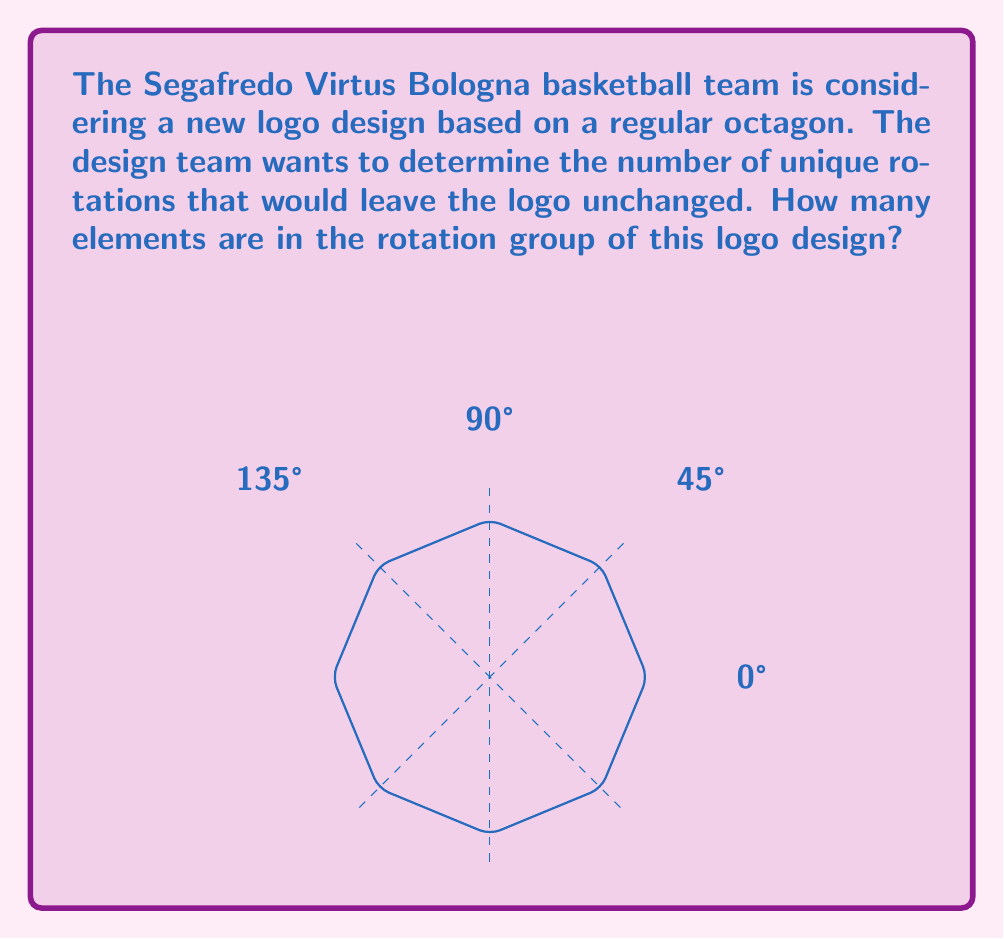What is the answer to this math problem? To determine the order of the rotation group for the octagonal logo, we need to consider the following steps:

1) A regular octagon has 8 vertices and 8 lines of symmetry.

2) The rotation group of a regular octagon consists of rotations that leave the shape unchanged.

3) The possible rotations are:
   $$0°, 45°, 90°, 135°, 180°, 225°, 270°, 315°$$

4) We can express these rotations as multiples of 45°:
   $$0°, 1(45°), 2(45°), 3(45°), 4(45°), 5(45°), 6(45°), 7(45°)$$

5) Each of these rotations brings the octagon back to a position indistinguishable from its original orientation.

6) The number of elements in the rotation group is equal to the number of these unique rotations.

7) Therefore, the order of the rotation group is 8.

In group theory terms, this rotation group is isomorphic to the cyclic group $C_8$ or $\mathbb{Z}/8\mathbb{Z}$.
Answer: 8 